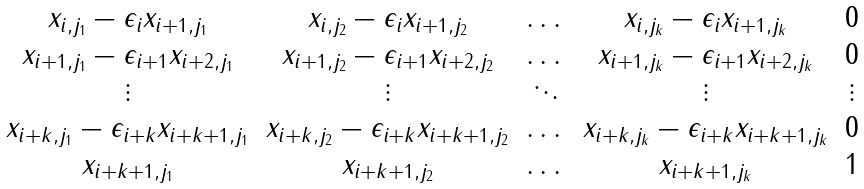<formula> <loc_0><loc_0><loc_500><loc_500>\begin{matrix} x _ { i , j _ { 1 } } - \epsilon _ { i } x _ { i + 1 , j _ { 1 } } & x _ { i , j _ { 2 } } - \epsilon _ { i } x _ { i + 1 , j _ { 2 } } & \dots & x _ { i , j _ { k } } - \epsilon _ { i } x _ { i + 1 , j _ { k } } & 0 \\ x _ { i + 1 , j _ { 1 } } - \epsilon _ { i + 1 } x _ { i + 2 , j _ { 1 } } & x _ { i + 1 , j _ { 2 } } - \epsilon _ { i + 1 } x _ { i + 2 , j _ { 2 } } & \dots & x _ { i + 1 , j _ { k } } - \epsilon _ { i + 1 } x _ { i + 2 , j _ { k } } & 0 \\ \vdots & \vdots & \ddots & \vdots & \vdots \\ x _ { i + k , j _ { 1 } } - \epsilon _ { i + k } x _ { i + k + 1 , j _ { 1 } } & x _ { i + k , j _ { 2 } } - \epsilon _ { i + k } x _ { i + k + 1 , j _ { 2 } } & \dots & x _ { i + k , j _ { k } } - \epsilon _ { i + k } x _ { i + k + 1 , j _ { k } } & 0 \\ x _ { i + k + 1 , j _ { 1 } } & x _ { i + k + 1 , j _ { 2 } } & \dots & x _ { i + k + 1 , j _ { k } } & 1 \end{matrix}</formula> 